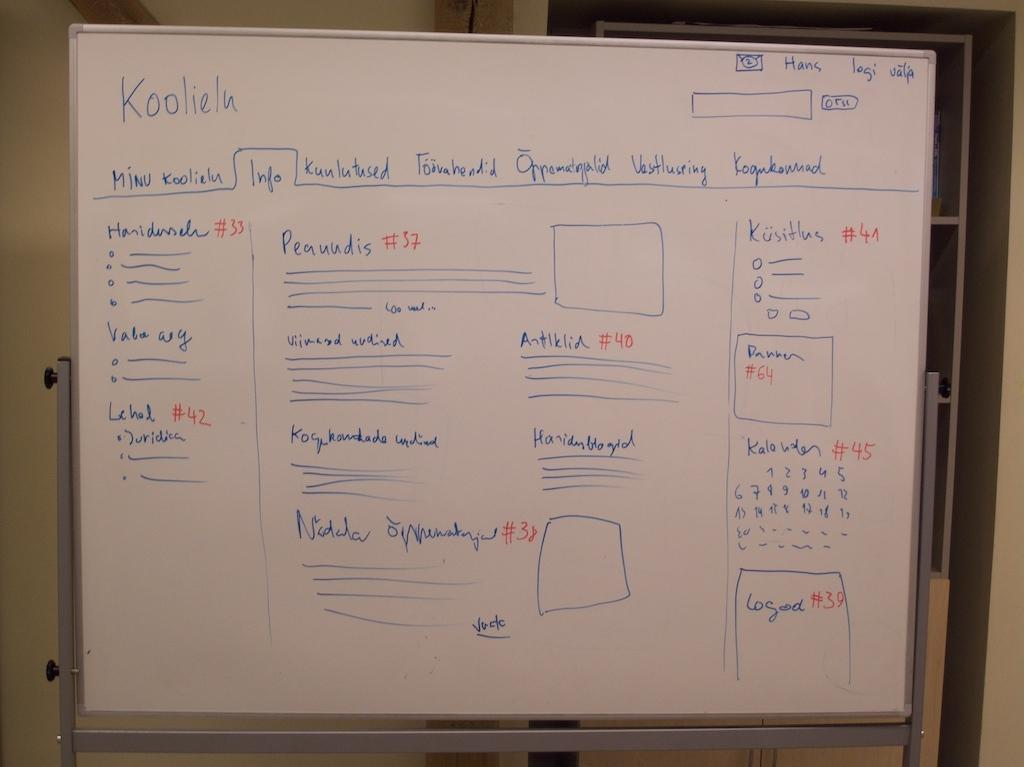<image>
Summarize the visual content of the image. A white board with Koolielu written in the upper left corner. 